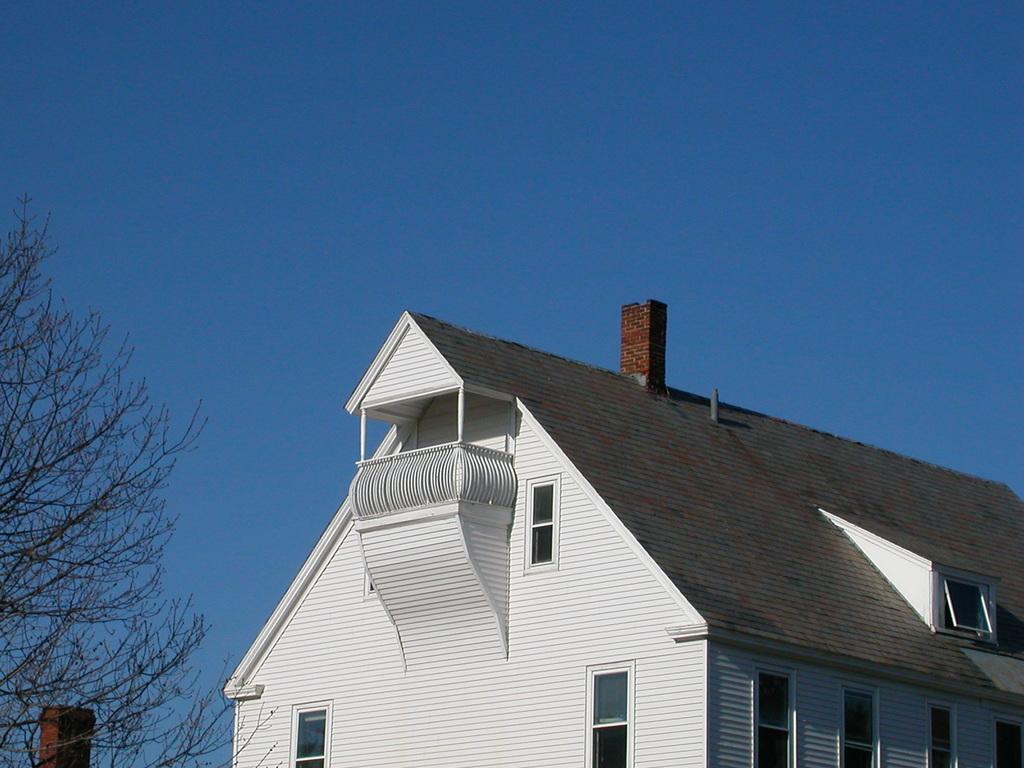In one or two sentences, can you explain what this image depicts? In the center of the image a building, windows are there. On the left side of the image tree, pole are present. In the background of the image sky is there. 